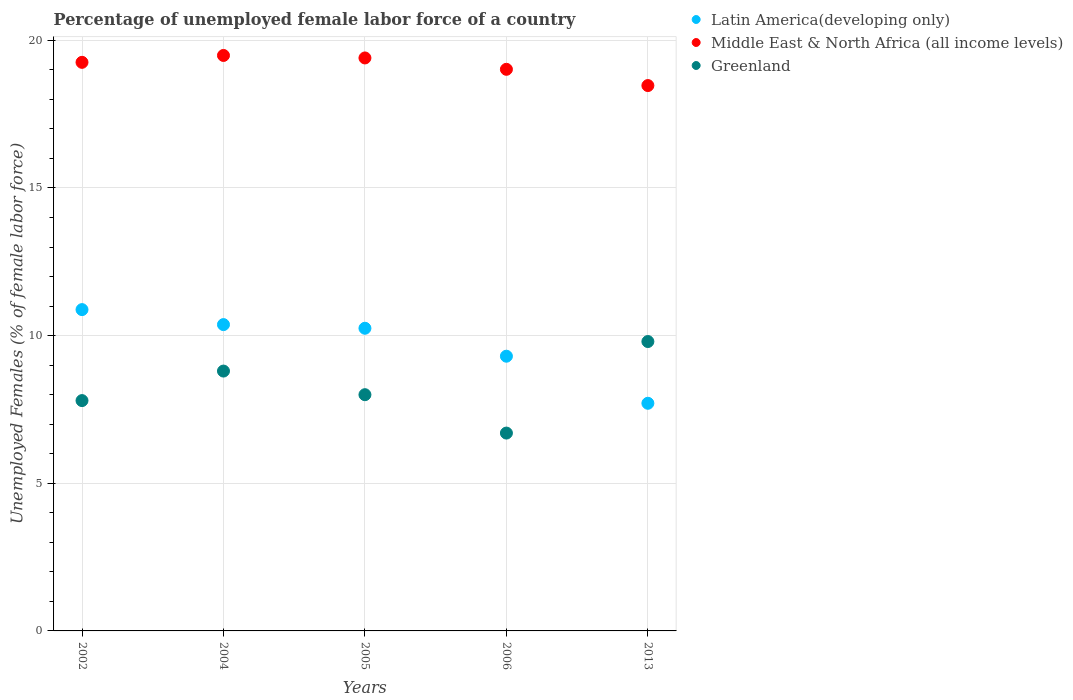Is the number of dotlines equal to the number of legend labels?
Your answer should be compact. Yes. What is the percentage of unemployed female labor force in Latin America(developing only) in 2004?
Give a very brief answer. 10.37. Across all years, what is the maximum percentage of unemployed female labor force in Middle East & North Africa (all income levels)?
Your response must be concise. 19.49. Across all years, what is the minimum percentage of unemployed female labor force in Middle East & North Africa (all income levels)?
Ensure brevity in your answer.  18.47. What is the total percentage of unemployed female labor force in Greenland in the graph?
Offer a very short reply. 41.1. What is the difference between the percentage of unemployed female labor force in Latin America(developing only) in 2004 and that in 2013?
Make the answer very short. 2.66. What is the difference between the percentage of unemployed female labor force in Middle East & North Africa (all income levels) in 2013 and the percentage of unemployed female labor force in Greenland in 2005?
Give a very brief answer. 10.47. What is the average percentage of unemployed female labor force in Middle East & North Africa (all income levels) per year?
Give a very brief answer. 19.13. In the year 2002, what is the difference between the percentage of unemployed female labor force in Middle East & North Africa (all income levels) and percentage of unemployed female labor force in Latin America(developing only)?
Provide a short and direct response. 8.37. In how many years, is the percentage of unemployed female labor force in Latin America(developing only) greater than 13 %?
Keep it short and to the point. 0. What is the ratio of the percentage of unemployed female labor force in Middle East & North Africa (all income levels) in 2004 to that in 2006?
Make the answer very short. 1.02. Is the difference between the percentage of unemployed female labor force in Middle East & North Africa (all income levels) in 2002 and 2013 greater than the difference between the percentage of unemployed female labor force in Latin America(developing only) in 2002 and 2013?
Provide a succinct answer. No. What is the difference between the highest and the lowest percentage of unemployed female labor force in Latin America(developing only)?
Offer a very short reply. 3.17. In how many years, is the percentage of unemployed female labor force in Latin America(developing only) greater than the average percentage of unemployed female labor force in Latin America(developing only) taken over all years?
Provide a short and direct response. 3. Is the sum of the percentage of unemployed female labor force in Greenland in 2005 and 2006 greater than the maximum percentage of unemployed female labor force in Latin America(developing only) across all years?
Give a very brief answer. Yes. Is it the case that in every year, the sum of the percentage of unemployed female labor force in Latin America(developing only) and percentage of unemployed female labor force in Greenland  is greater than the percentage of unemployed female labor force in Middle East & North Africa (all income levels)?
Make the answer very short. No. Does the percentage of unemployed female labor force in Middle East & North Africa (all income levels) monotonically increase over the years?
Give a very brief answer. No. Is the percentage of unemployed female labor force in Middle East & North Africa (all income levels) strictly greater than the percentage of unemployed female labor force in Latin America(developing only) over the years?
Your response must be concise. Yes. Is the percentage of unemployed female labor force in Middle East & North Africa (all income levels) strictly less than the percentage of unemployed female labor force in Latin America(developing only) over the years?
Provide a short and direct response. No. Does the graph contain grids?
Provide a short and direct response. Yes. Where does the legend appear in the graph?
Your response must be concise. Top right. How are the legend labels stacked?
Your response must be concise. Vertical. What is the title of the graph?
Provide a short and direct response. Percentage of unemployed female labor force of a country. What is the label or title of the X-axis?
Give a very brief answer. Years. What is the label or title of the Y-axis?
Ensure brevity in your answer.  Unemployed Females (% of female labor force). What is the Unemployed Females (% of female labor force) of Latin America(developing only) in 2002?
Give a very brief answer. 10.88. What is the Unemployed Females (% of female labor force) of Middle East & North Africa (all income levels) in 2002?
Ensure brevity in your answer.  19.26. What is the Unemployed Females (% of female labor force) in Greenland in 2002?
Offer a very short reply. 7.8. What is the Unemployed Females (% of female labor force) in Latin America(developing only) in 2004?
Make the answer very short. 10.37. What is the Unemployed Females (% of female labor force) of Middle East & North Africa (all income levels) in 2004?
Your answer should be compact. 19.49. What is the Unemployed Females (% of female labor force) of Greenland in 2004?
Make the answer very short. 8.8. What is the Unemployed Females (% of female labor force) of Latin America(developing only) in 2005?
Ensure brevity in your answer.  10.25. What is the Unemployed Females (% of female labor force) in Middle East & North Africa (all income levels) in 2005?
Offer a terse response. 19.4. What is the Unemployed Females (% of female labor force) in Latin America(developing only) in 2006?
Make the answer very short. 9.3. What is the Unemployed Females (% of female labor force) in Middle East & North Africa (all income levels) in 2006?
Make the answer very short. 19.02. What is the Unemployed Females (% of female labor force) of Greenland in 2006?
Your answer should be very brief. 6.7. What is the Unemployed Females (% of female labor force) of Latin America(developing only) in 2013?
Provide a succinct answer. 7.71. What is the Unemployed Females (% of female labor force) in Middle East & North Africa (all income levels) in 2013?
Provide a succinct answer. 18.47. What is the Unemployed Females (% of female labor force) of Greenland in 2013?
Offer a very short reply. 9.8. Across all years, what is the maximum Unemployed Females (% of female labor force) in Latin America(developing only)?
Offer a terse response. 10.88. Across all years, what is the maximum Unemployed Females (% of female labor force) in Middle East & North Africa (all income levels)?
Offer a terse response. 19.49. Across all years, what is the maximum Unemployed Females (% of female labor force) of Greenland?
Your answer should be very brief. 9.8. Across all years, what is the minimum Unemployed Females (% of female labor force) of Latin America(developing only)?
Provide a succinct answer. 7.71. Across all years, what is the minimum Unemployed Females (% of female labor force) in Middle East & North Africa (all income levels)?
Keep it short and to the point. 18.47. Across all years, what is the minimum Unemployed Females (% of female labor force) of Greenland?
Offer a terse response. 6.7. What is the total Unemployed Females (% of female labor force) in Latin America(developing only) in the graph?
Your answer should be compact. 48.52. What is the total Unemployed Females (% of female labor force) of Middle East & North Africa (all income levels) in the graph?
Make the answer very short. 95.63. What is the total Unemployed Females (% of female labor force) in Greenland in the graph?
Provide a short and direct response. 41.1. What is the difference between the Unemployed Females (% of female labor force) of Latin America(developing only) in 2002 and that in 2004?
Your answer should be compact. 0.51. What is the difference between the Unemployed Females (% of female labor force) in Middle East & North Africa (all income levels) in 2002 and that in 2004?
Your answer should be compact. -0.23. What is the difference between the Unemployed Females (% of female labor force) of Greenland in 2002 and that in 2004?
Your answer should be compact. -1. What is the difference between the Unemployed Females (% of female labor force) of Latin America(developing only) in 2002 and that in 2005?
Provide a succinct answer. 0.63. What is the difference between the Unemployed Females (% of female labor force) of Middle East & North Africa (all income levels) in 2002 and that in 2005?
Keep it short and to the point. -0.15. What is the difference between the Unemployed Females (% of female labor force) in Latin America(developing only) in 2002 and that in 2006?
Provide a succinct answer. 1.58. What is the difference between the Unemployed Females (% of female labor force) of Middle East & North Africa (all income levels) in 2002 and that in 2006?
Make the answer very short. 0.24. What is the difference between the Unemployed Females (% of female labor force) of Greenland in 2002 and that in 2006?
Give a very brief answer. 1.1. What is the difference between the Unemployed Females (% of female labor force) in Latin America(developing only) in 2002 and that in 2013?
Provide a succinct answer. 3.17. What is the difference between the Unemployed Females (% of female labor force) of Middle East & North Africa (all income levels) in 2002 and that in 2013?
Your response must be concise. 0.79. What is the difference between the Unemployed Females (% of female labor force) of Latin America(developing only) in 2004 and that in 2005?
Make the answer very short. 0.12. What is the difference between the Unemployed Females (% of female labor force) of Middle East & North Africa (all income levels) in 2004 and that in 2005?
Give a very brief answer. 0.08. What is the difference between the Unemployed Females (% of female labor force) in Greenland in 2004 and that in 2005?
Your answer should be very brief. 0.8. What is the difference between the Unemployed Females (% of female labor force) in Latin America(developing only) in 2004 and that in 2006?
Provide a succinct answer. 1.07. What is the difference between the Unemployed Females (% of female labor force) of Middle East & North Africa (all income levels) in 2004 and that in 2006?
Provide a succinct answer. 0.47. What is the difference between the Unemployed Females (% of female labor force) in Latin America(developing only) in 2004 and that in 2013?
Make the answer very short. 2.66. What is the difference between the Unemployed Females (% of female labor force) of Middle East & North Africa (all income levels) in 2004 and that in 2013?
Provide a succinct answer. 1.02. What is the difference between the Unemployed Females (% of female labor force) in Latin America(developing only) in 2005 and that in 2006?
Your response must be concise. 0.95. What is the difference between the Unemployed Females (% of female labor force) of Middle East & North Africa (all income levels) in 2005 and that in 2006?
Keep it short and to the point. 0.38. What is the difference between the Unemployed Females (% of female labor force) in Greenland in 2005 and that in 2006?
Provide a succinct answer. 1.3. What is the difference between the Unemployed Females (% of female labor force) in Latin America(developing only) in 2005 and that in 2013?
Your response must be concise. 2.54. What is the difference between the Unemployed Females (% of female labor force) of Middle East & North Africa (all income levels) in 2005 and that in 2013?
Keep it short and to the point. 0.94. What is the difference between the Unemployed Females (% of female labor force) in Greenland in 2005 and that in 2013?
Make the answer very short. -1.8. What is the difference between the Unemployed Females (% of female labor force) in Latin America(developing only) in 2006 and that in 2013?
Ensure brevity in your answer.  1.59. What is the difference between the Unemployed Females (% of female labor force) of Middle East & North Africa (all income levels) in 2006 and that in 2013?
Offer a very short reply. 0.55. What is the difference between the Unemployed Females (% of female labor force) in Greenland in 2006 and that in 2013?
Your response must be concise. -3.1. What is the difference between the Unemployed Females (% of female labor force) of Latin America(developing only) in 2002 and the Unemployed Females (% of female labor force) of Middle East & North Africa (all income levels) in 2004?
Your response must be concise. -8.61. What is the difference between the Unemployed Females (% of female labor force) of Latin America(developing only) in 2002 and the Unemployed Females (% of female labor force) of Greenland in 2004?
Your response must be concise. 2.08. What is the difference between the Unemployed Females (% of female labor force) in Middle East & North Africa (all income levels) in 2002 and the Unemployed Females (% of female labor force) in Greenland in 2004?
Provide a succinct answer. 10.46. What is the difference between the Unemployed Females (% of female labor force) in Latin America(developing only) in 2002 and the Unemployed Females (% of female labor force) in Middle East & North Africa (all income levels) in 2005?
Provide a succinct answer. -8.52. What is the difference between the Unemployed Females (% of female labor force) of Latin America(developing only) in 2002 and the Unemployed Females (% of female labor force) of Greenland in 2005?
Provide a succinct answer. 2.88. What is the difference between the Unemployed Females (% of female labor force) of Middle East & North Africa (all income levels) in 2002 and the Unemployed Females (% of female labor force) of Greenland in 2005?
Make the answer very short. 11.26. What is the difference between the Unemployed Females (% of female labor force) of Latin America(developing only) in 2002 and the Unemployed Females (% of female labor force) of Middle East & North Africa (all income levels) in 2006?
Your response must be concise. -8.14. What is the difference between the Unemployed Females (% of female labor force) of Latin America(developing only) in 2002 and the Unemployed Females (% of female labor force) of Greenland in 2006?
Make the answer very short. 4.18. What is the difference between the Unemployed Females (% of female labor force) in Middle East & North Africa (all income levels) in 2002 and the Unemployed Females (% of female labor force) in Greenland in 2006?
Your answer should be very brief. 12.56. What is the difference between the Unemployed Females (% of female labor force) in Latin America(developing only) in 2002 and the Unemployed Females (% of female labor force) in Middle East & North Africa (all income levels) in 2013?
Offer a very short reply. -7.59. What is the difference between the Unemployed Females (% of female labor force) in Latin America(developing only) in 2002 and the Unemployed Females (% of female labor force) in Greenland in 2013?
Offer a very short reply. 1.08. What is the difference between the Unemployed Females (% of female labor force) in Middle East & North Africa (all income levels) in 2002 and the Unemployed Females (% of female labor force) in Greenland in 2013?
Offer a terse response. 9.46. What is the difference between the Unemployed Females (% of female labor force) of Latin America(developing only) in 2004 and the Unemployed Females (% of female labor force) of Middle East & North Africa (all income levels) in 2005?
Provide a succinct answer. -9.03. What is the difference between the Unemployed Females (% of female labor force) in Latin America(developing only) in 2004 and the Unemployed Females (% of female labor force) in Greenland in 2005?
Provide a succinct answer. 2.37. What is the difference between the Unemployed Females (% of female labor force) in Middle East & North Africa (all income levels) in 2004 and the Unemployed Females (% of female labor force) in Greenland in 2005?
Offer a very short reply. 11.49. What is the difference between the Unemployed Females (% of female labor force) in Latin America(developing only) in 2004 and the Unemployed Females (% of female labor force) in Middle East & North Africa (all income levels) in 2006?
Ensure brevity in your answer.  -8.65. What is the difference between the Unemployed Females (% of female labor force) of Latin America(developing only) in 2004 and the Unemployed Females (% of female labor force) of Greenland in 2006?
Make the answer very short. 3.67. What is the difference between the Unemployed Females (% of female labor force) of Middle East & North Africa (all income levels) in 2004 and the Unemployed Females (% of female labor force) of Greenland in 2006?
Ensure brevity in your answer.  12.79. What is the difference between the Unemployed Females (% of female labor force) of Latin America(developing only) in 2004 and the Unemployed Females (% of female labor force) of Middle East & North Africa (all income levels) in 2013?
Provide a short and direct response. -8.1. What is the difference between the Unemployed Females (% of female labor force) in Latin America(developing only) in 2004 and the Unemployed Females (% of female labor force) in Greenland in 2013?
Keep it short and to the point. 0.57. What is the difference between the Unemployed Females (% of female labor force) in Middle East & North Africa (all income levels) in 2004 and the Unemployed Females (% of female labor force) in Greenland in 2013?
Your answer should be very brief. 9.69. What is the difference between the Unemployed Females (% of female labor force) in Latin America(developing only) in 2005 and the Unemployed Females (% of female labor force) in Middle East & North Africa (all income levels) in 2006?
Provide a succinct answer. -8.77. What is the difference between the Unemployed Females (% of female labor force) of Latin America(developing only) in 2005 and the Unemployed Females (% of female labor force) of Greenland in 2006?
Provide a short and direct response. 3.55. What is the difference between the Unemployed Females (% of female labor force) of Middle East & North Africa (all income levels) in 2005 and the Unemployed Females (% of female labor force) of Greenland in 2006?
Offer a terse response. 12.7. What is the difference between the Unemployed Females (% of female labor force) in Latin America(developing only) in 2005 and the Unemployed Females (% of female labor force) in Middle East & North Africa (all income levels) in 2013?
Ensure brevity in your answer.  -8.22. What is the difference between the Unemployed Females (% of female labor force) of Latin America(developing only) in 2005 and the Unemployed Females (% of female labor force) of Greenland in 2013?
Offer a terse response. 0.45. What is the difference between the Unemployed Females (% of female labor force) of Middle East & North Africa (all income levels) in 2005 and the Unemployed Females (% of female labor force) of Greenland in 2013?
Provide a short and direct response. 9.6. What is the difference between the Unemployed Females (% of female labor force) in Latin America(developing only) in 2006 and the Unemployed Females (% of female labor force) in Middle East & North Africa (all income levels) in 2013?
Provide a short and direct response. -9.17. What is the difference between the Unemployed Females (% of female labor force) in Latin America(developing only) in 2006 and the Unemployed Females (% of female labor force) in Greenland in 2013?
Provide a succinct answer. -0.5. What is the difference between the Unemployed Females (% of female labor force) in Middle East & North Africa (all income levels) in 2006 and the Unemployed Females (% of female labor force) in Greenland in 2013?
Offer a very short reply. 9.22. What is the average Unemployed Females (% of female labor force) of Latin America(developing only) per year?
Give a very brief answer. 9.7. What is the average Unemployed Females (% of female labor force) in Middle East & North Africa (all income levels) per year?
Give a very brief answer. 19.13. What is the average Unemployed Females (% of female labor force) in Greenland per year?
Offer a terse response. 8.22. In the year 2002, what is the difference between the Unemployed Females (% of female labor force) in Latin America(developing only) and Unemployed Females (% of female labor force) in Middle East & North Africa (all income levels)?
Provide a short and direct response. -8.37. In the year 2002, what is the difference between the Unemployed Females (% of female labor force) in Latin America(developing only) and Unemployed Females (% of female labor force) in Greenland?
Offer a very short reply. 3.08. In the year 2002, what is the difference between the Unemployed Females (% of female labor force) of Middle East & North Africa (all income levels) and Unemployed Females (% of female labor force) of Greenland?
Your answer should be very brief. 11.46. In the year 2004, what is the difference between the Unemployed Females (% of female labor force) in Latin America(developing only) and Unemployed Females (% of female labor force) in Middle East & North Africa (all income levels)?
Make the answer very short. -9.11. In the year 2004, what is the difference between the Unemployed Females (% of female labor force) in Latin America(developing only) and Unemployed Females (% of female labor force) in Greenland?
Give a very brief answer. 1.57. In the year 2004, what is the difference between the Unemployed Females (% of female labor force) of Middle East & North Africa (all income levels) and Unemployed Females (% of female labor force) of Greenland?
Offer a terse response. 10.69. In the year 2005, what is the difference between the Unemployed Females (% of female labor force) in Latin America(developing only) and Unemployed Females (% of female labor force) in Middle East & North Africa (all income levels)?
Provide a short and direct response. -9.15. In the year 2005, what is the difference between the Unemployed Females (% of female labor force) in Latin America(developing only) and Unemployed Females (% of female labor force) in Greenland?
Offer a very short reply. 2.25. In the year 2005, what is the difference between the Unemployed Females (% of female labor force) in Middle East & North Africa (all income levels) and Unemployed Females (% of female labor force) in Greenland?
Your answer should be compact. 11.4. In the year 2006, what is the difference between the Unemployed Females (% of female labor force) in Latin America(developing only) and Unemployed Females (% of female labor force) in Middle East & North Africa (all income levels)?
Your response must be concise. -9.72. In the year 2006, what is the difference between the Unemployed Females (% of female labor force) of Latin America(developing only) and Unemployed Females (% of female labor force) of Greenland?
Provide a short and direct response. 2.6. In the year 2006, what is the difference between the Unemployed Females (% of female labor force) in Middle East & North Africa (all income levels) and Unemployed Females (% of female labor force) in Greenland?
Ensure brevity in your answer.  12.32. In the year 2013, what is the difference between the Unemployed Females (% of female labor force) of Latin America(developing only) and Unemployed Females (% of female labor force) of Middle East & North Africa (all income levels)?
Offer a terse response. -10.76. In the year 2013, what is the difference between the Unemployed Females (% of female labor force) in Latin America(developing only) and Unemployed Females (% of female labor force) in Greenland?
Ensure brevity in your answer.  -2.09. In the year 2013, what is the difference between the Unemployed Females (% of female labor force) in Middle East & North Africa (all income levels) and Unemployed Females (% of female labor force) in Greenland?
Keep it short and to the point. 8.67. What is the ratio of the Unemployed Females (% of female labor force) in Latin America(developing only) in 2002 to that in 2004?
Provide a succinct answer. 1.05. What is the ratio of the Unemployed Females (% of female labor force) in Greenland in 2002 to that in 2004?
Your answer should be compact. 0.89. What is the ratio of the Unemployed Females (% of female labor force) in Latin America(developing only) in 2002 to that in 2005?
Offer a terse response. 1.06. What is the ratio of the Unemployed Females (% of female labor force) of Greenland in 2002 to that in 2005?
Ensure brevity in your answer.  0.97. What is the ratio of the Unemployed Females (% of female labor force) in Latin America(developing only) in 2002 to that in 2006?
Provide a succinct answer. 1.17. What is the ratio of the Unemployed Females (% of female labor force) of Middle East & North Africa (all income levels) in 2002 to that in 2006?
Make the answer very short. 1.01. What is the ratio of the Unemployed Females (% of female labor force) in Greenland in 2002 to that in 2006?
Your answer should be compact. 1.16. What is the ratio of the Unemployed Females (% of female labor force) in Latin America(developing only) in 2002 to that in 2013?
Make the answer very short. 1.41. What is the ratio of the Unemployed Females (% of female labor force) of Middle East & North Africa (all income levels) in 2002 to that in 2013?
Offer a very short reply. 1.04. What is the ratio of the Unemployed Females (% of female labor force) of Greenland in 2002 to that in 2013?
Give a very brief answer. 0.8. What is the ratio of the Unemployed Females (% of female labor force) of Latin America(developing only) in 2004 to that in 2005?
Keep it short and to the point. 1.01. What is the ratio of the Unemployed Females (% of female labor force) of Greenland in 2004 to that in 2005?
Keep it short and to the point. 1.1. What is the ratio of the Unemployed Females (% of female labor force) in Latin America(developing only) in 2004 to that in 2006?
Ensure brevity in your answer.  1.11. What is the ratio of the Unemployed Females (% of female labor force) of Middle East & North Africa (all income levels) in 2004 to that in 2006?
Provide a succinct answer. 1.02. What is the ratio of the Unemployed Females (% of female labor force) of Greenland in 2004 to that in 2006?
Your response must be concise. 1.31. What is the ratio of the Unemployed Females (% of female labor force) in Latin America(developing only) in 2004 to that in 2013?
Give a very brief answer. 1.35. What is the ratio of the Unemployed Females (% of female labor force) of Middle East & North Africa (all income levels) in 2004 to that in 2013?
Offer a terse response. 1.06. What is the ratio of the Unemployed Females (% of female labor force) in Greenland in 2004 to that in 2013?
Ensure brevity in your answer.  0.9. What is the ratio of the Unemployed Females (% of female labor force) in Latin America(developing only) in 2005 to that in 2006?
Your answer should be compact. 1.1. What is the ratio of the Unemployed Females (% of female labor force) in Middle East & North Africa (all income levels) in 2005 to that in 2006?
Offer a terse response. 1.02. What is the ratio of the Unemployed Females (% of female labor force) of Greenland in 2005 to that in 2006?
Give a very brief answer. 1.19. What is the ratio of the Unemployed Females (% of female labor force) of Latin America(developing only) in 2005 to that in 2013?
Offer a very short reply. 1.33. What is the ratio of the Unemployed Females (% of female labor force) in Middle East & North Africa (all income levels) in 2005 to that in 2013?
Your answer should be very brief. 1.05. What is the ratio of the Unemployed Females (% of female labor force) in Greenland in 2005 to that in 2013?
Offer a very short reply. 0.82. What is the ratio of the Unemployed Females (% of female labor force) of Latin America(developing only) in 2006 to that in 2013?
Your response must be concise. 1.21. What is the ratio of the Unemployed Females (% of female labor force) of Middle East & North Africa (all income levels) in 2006 to that in 2013?
Provide a short and direct response. 1.03. What is the ratio of the Unemployed Females (% of female labor force) of Greenland in 2006 to that in 2013?
Offer a terse response. 0.68. What is the difference between the highest and the second highest Unemployed Females (% of female labor force) of Latin America(developing only)?
Offer a terse response. 0.51. What is the difference between the highest and the second highest Unemployed Females (% of female labor force) of Middle East & North Africa (all income levels)?
Make the answer very short. 0.08. What is the difference between the highest and the lowest Unemployed Females (% of female labor force) in Latin America(developing only)?
Offer a very short reply. 3.17. What is the difference between the highest and the lowest Unemployed Females (% of female labor force) in Middle East & North Africa (all income levels)?
Your answer should be compact. 1.02. 